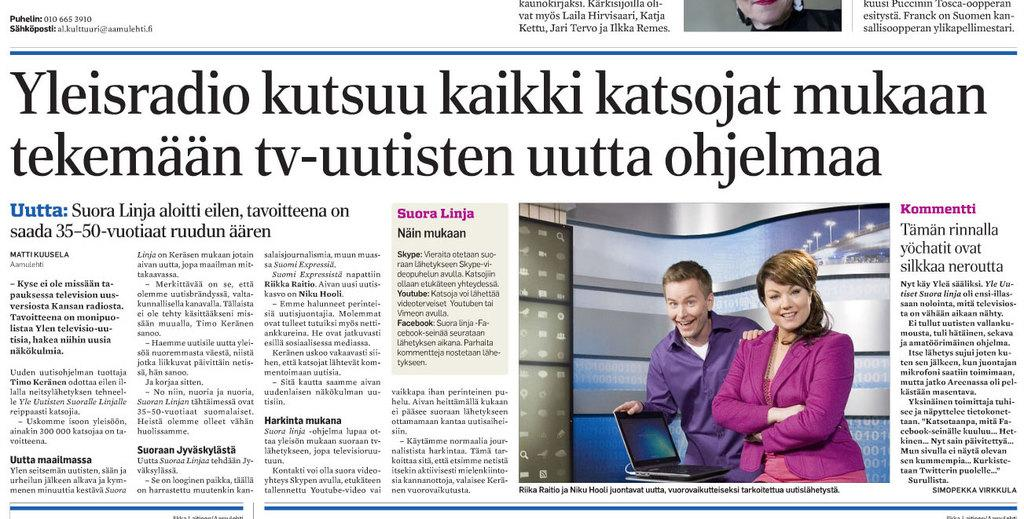What is the main subject of the image? The main subject of the image is a picture of a newspaper. What else can be seen in the image besides the newspaper? There are letters visible in the image, as well as a man standing and smiling, a woman standing and smiling, and a laptop on a table. What route does the liquid take in the image? There is no liquid present in the image, so it is not possible to determine a route. 